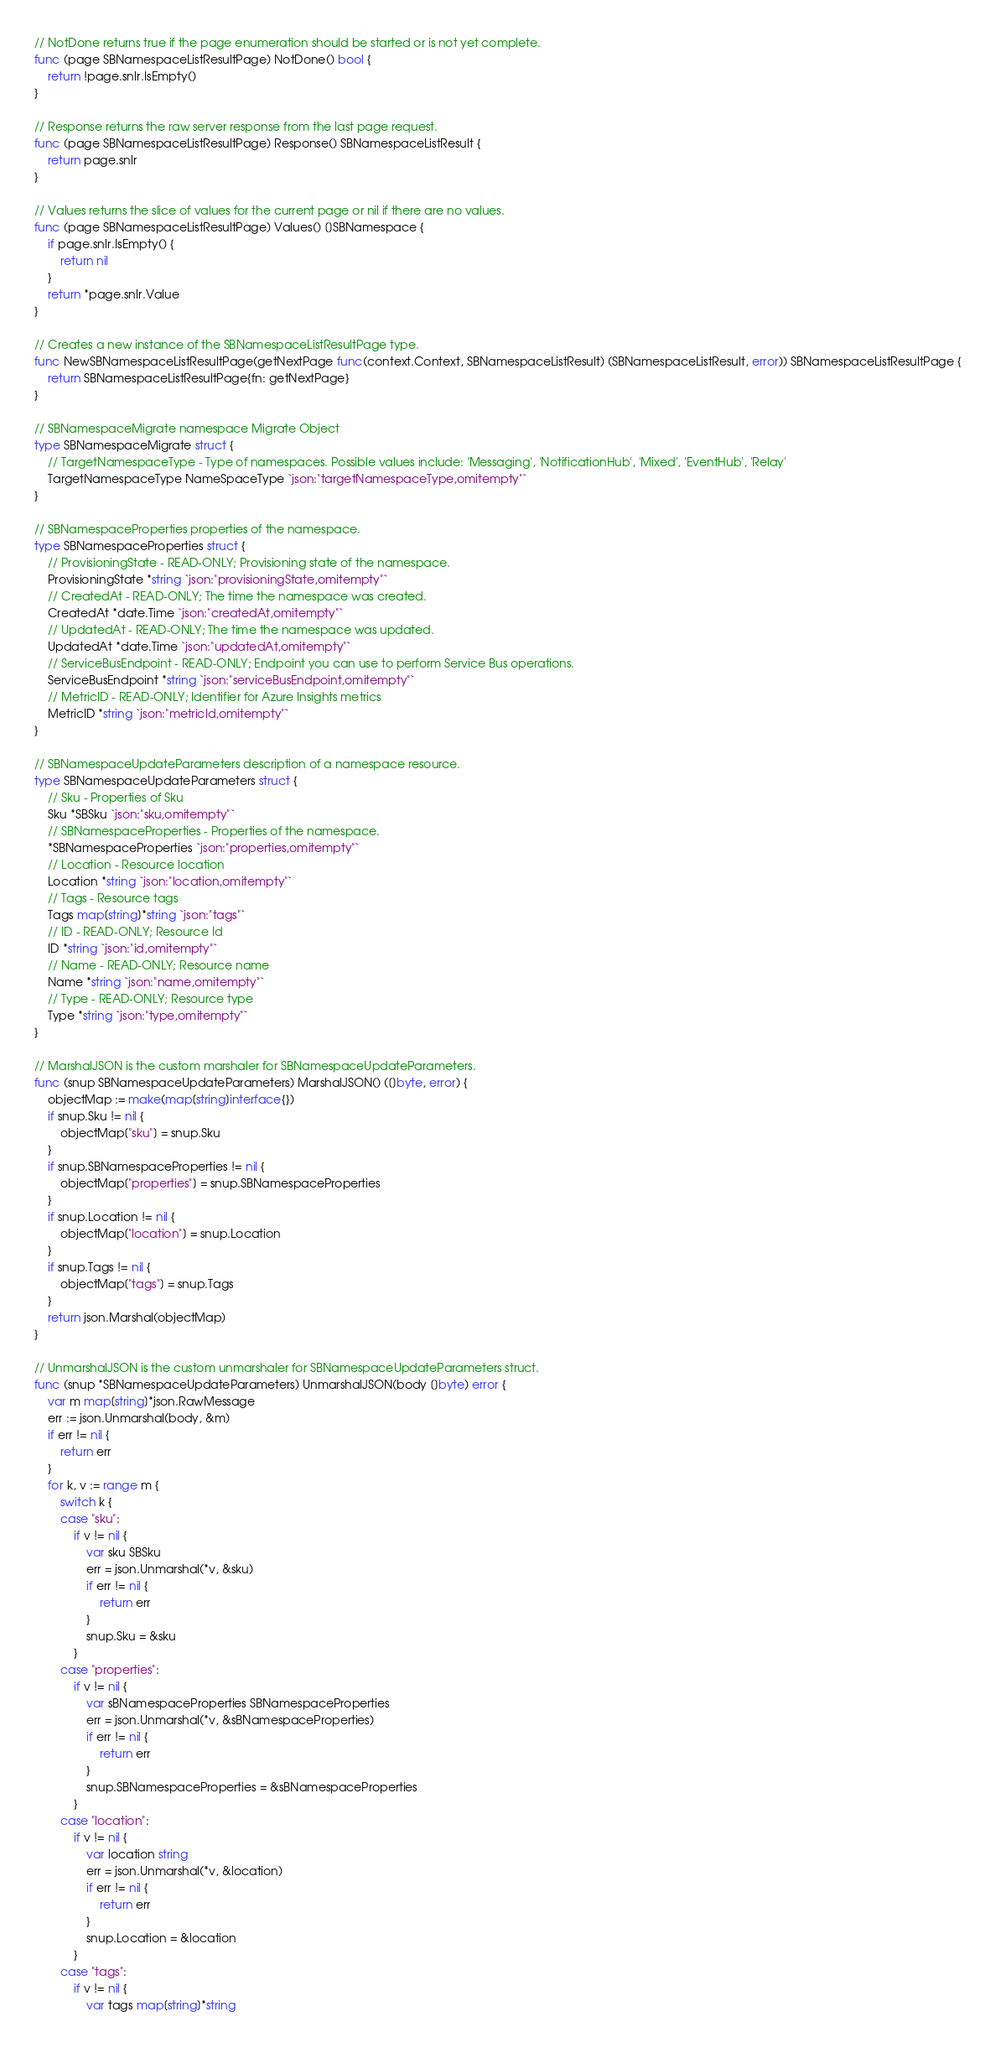Convert code to text. <code><loc_0><loc_0><loc_500><loc_500><_Go_>
// NotDone returns true if the page enumeration should be started or is not yet complete.
func (page SBNamespaceListResultPage) NotDone() bool {
	return !page.snlr.IsEmpty()
}

// Response returns the raw server response from the last page request.
func (page SBNamespaceListResultPage) Response() SBNamespaceListResult {
	return page.snlr
}

// Values returns the slice of values for the current page or nil if there are no values.
func (page SBNamespaceListResultPage) Values() []SBNamespace {
	if page.snlr.IsEmpty() {
		return nil
	}
	return *page.snlr.Value
}

// Creates a new instance of the SBNamespaceListResultPage type.
func NewSBNamespaceListResultPage(getNextPage func(context.Context, SBNamespaceListResult) (SBNamespaceListResult, error)) SBNamespaceListResultPage {
	return SBNamespaceListResultPage{fn: getNextPage}
}

// SBNamespaceMigrate namespace Migrate Object
type SBNamespaceMigrate struct {
	// TargetNamespaceType - Type of namespaces. Possible values include: 'Messaging', 'NotificationHub', 'Mixed', 'EventHub', 'Relay'
	TargetNamespaceType NameSpaceType `json:"targetNamespaceType,omitempty"`
}

// SBNamespaceProperties properties of the namespace.
type SBNamespaceProperties struct {
	// ProvisioningState - READ-ONLY; Provisioning state of the namespace.
	ProvisioningState *string `json:"provisioningState,omitempty"`
	// CreatedAt - READ-ONLY; The time the namespace was created.
	CreatedAt *date.Time `json:"createdAt,omitempty"`
	// UpdatedAt - READ-ONLY; The time the namespace was updated.
	UpdatedAt *date.Time `json:"updatedAt,omitempty"`
	// ServiceBusEndpoint - READ-ONLY; Endpoint you can use to perform Service Bus operations.
	ServiceBusEndpoint *string `json:"serviceBusEndpoint,omitempty"`
	// MetricID - READ-ONLY; Identifier for Azure Insights metrics
	MetricID *string `json:"metricId,omitempty"`
}

// SBNamespaceUpdateParameters description of a namespace resource.
type SBNamespaceUpdateParameters struct {
	// Sku - Properties of Sku
	Sku *SBSku `json:"sku,omitempty"`
	// SBNamespaceProperties - Properties of the namespace.
	*SBNamespaceProperties `json:"properties,omitempty"`
	// Location - Resource location
	Location *string `json:"location,omitempty"`
	// Tags - Resource tags
	Tags map[string]*string `json:"tags"`
	// ID - READ-ONLY; Resource Id
	ID *string `json:"id,omitempty"`
	// Name - READ-ONLY; Resource name
	Name *string `json:"name,omitempty"`
	// Type - READ-ONLY; Resource type
	Type *string `json:"type,omitempty"`
}

// MarshalJSON is the custom marshaler for SBNamespaceUpdateParameters.
func (snup SBNamespaceUpdateParameters) MarshalJSON() ([]byte, error) {
	objectMap := make(map[string]interface{})
	if snup.Sku != nil {
		objectMap["sku"] = snup.Sku
	}
	if snup.SBNamespaceProperties != nil {
		objectMap["properties"] = snup.SBNamespaceProperties
	}
	if snup.Location != nil {
		objectMap["location"] = snup.Location
	}
	if snup.Tags != nil {
		objectMap["tags"] = snup.Tags
	}
	return json.Marshal(objectMap)
}

// UnmarshalJSON is the custom unmarshaler for SBNamespaceUpdateParameters struct.
func (snup *SBNamespaceUpdateParameters) UnmarshalJSON(body []byte) error {
	var m map[string]*json.RawMessage
	err := json.Unmarshal(body, &m)
	if err != nil {
		return err
	}
	for k, v := range m {
		switch k {
		case "sku":
			if v != nil {
				var sku SBSku
				err = json.Unmarshal(*v, &sku)
				if err != nil {
					return err
				}
				snup.Sku = &sku
			}
		case "properties":
			if v != nil {
				var sBNamespaceProperties SBNamespaceProperties
				err = json.Unmarshal(*v, &sBNamespaceProperties)
				if err != nil {
					return err
				}
				snup.SBNamespaceProperties = &sBNamespaceProperties
			}
		case "location":
			if v != nil {
				var location string
				err = json.Unmarshal(*v, &location)
				if err != nil {
					return err
				}
				snup.Location = &location
			}
		case "tags":
			if v != nil {
				var tags map[string]*string</code> 